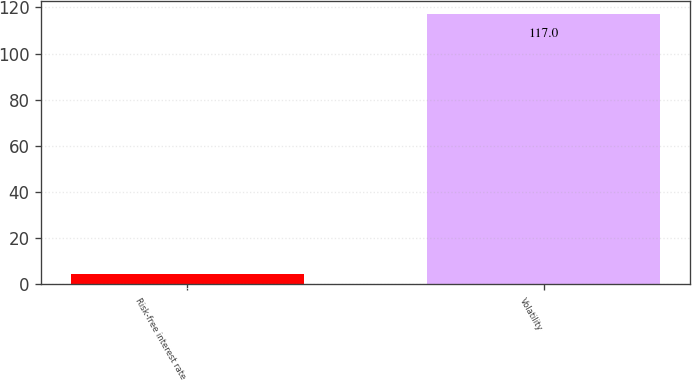<chart> <loc_0><loc_0><loc_500><loc_500><bar_chart><fcel>Risk-free interest rate<fcel>Volatility<nl><fcel>4.36<fcel>117<nl></chart> 